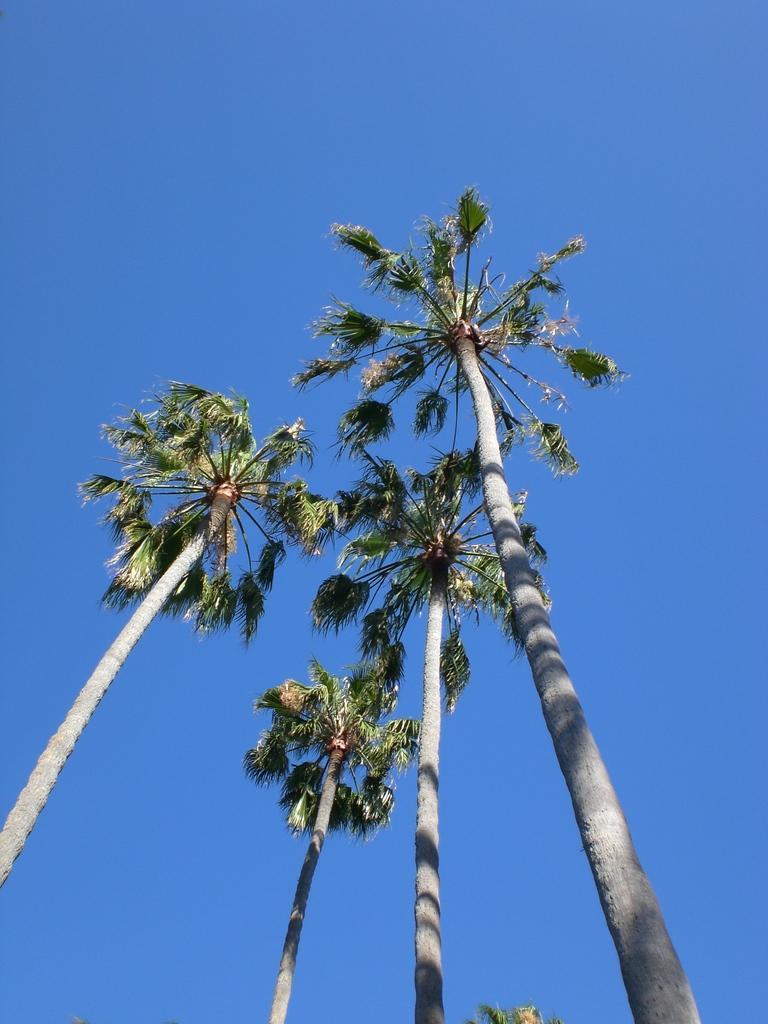How would you summarize this image in a sentence or two? In this image we can see some trees. On the backside we can see the sky. 